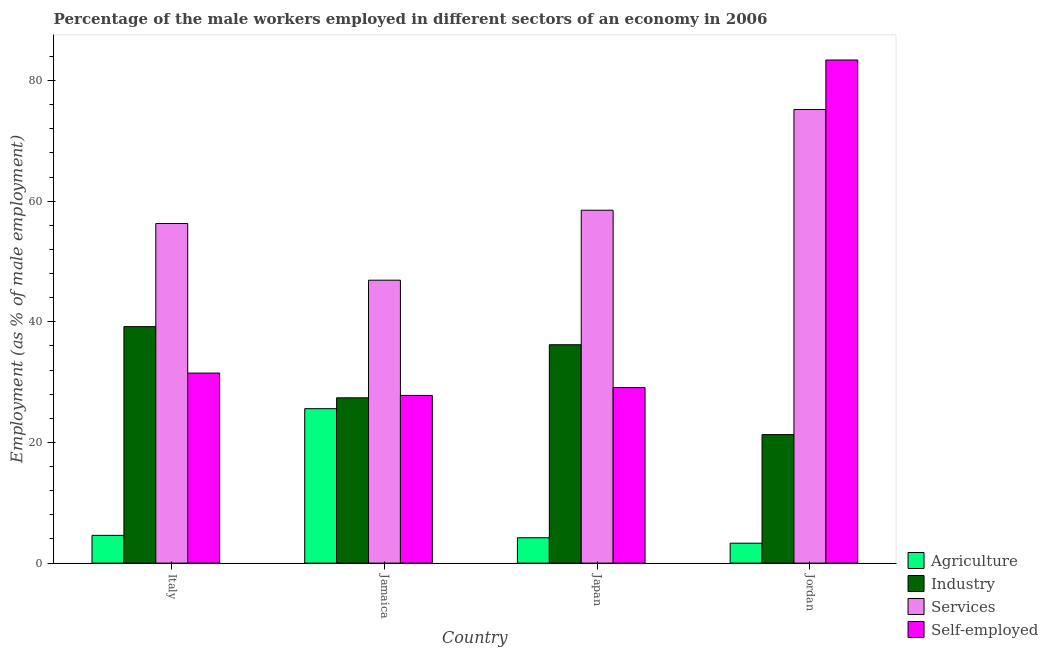How many different coloured bars are there?
Your answer should be compact. 4. How many groups of bars are there?
Give a very brief answer. 4. Are the number of bars per tick equal to the number of legend labels?
Your answer should be compact. Yes. Are the number of bars on each tick of the X-axis equal?
Provide a succinct answer. Yes. What is the percentage of self employed male workers in Jamaica?
Your answer should be compact. 27.8. Across all countries, what is the maximum percentage of self employed male workers?
Provide a short and direct response. 83.4. Across all countries, what is the minimum percentage of self employed male workers?
Keep it short and to the point. 27.8. In which country was the percentage of male workers in agriculture maximum?
Offer a terse response. Jamaica. In which country was the percentage of male workers in industry minimum?
Provide a short and direct response. Jordan. What is the total percentage of male workers in services in the graph?
Give a very brief answer. 236.9. What is the difference between the percentage of male workers in services in Italy and that in Jordan?
Keep it short and to the point. -18.9. What is the difference between the percentage of male workers in industry in Italy and the percentage of male workers in agriculture in Japan?
Offer a very short reply. 35. What is the average percentage of male workers in industry per country?
Provide a succinct answer. 31.03. What is the difference between the percentage of male workers in services and percentage of self employed male workers in Japan?
Offer a very short reply. 29.4. What is the ratio of the percentage of male workers in services in Italy to that in Jordan?
Your answer should be very brief. 0.75. Is the percentage of male workers in services in Jamaica less than that in Jordan?
Give a very brief answer. Yes. What is the difference between the highest and the lowest percentage of male workers in services?
Keep it short and to the point. 28.3. In how many countries, is the percentage of self employed male workers greater than the average percentage of self employed male workers taken over all countries?
Offer a very short reply. 1. Is the sum of the percentage of self employed male workers in Italy and Jordan greater than the maximum percentage of male workers in services across all countries?
Ensure brevity in your answer.  Yes. Is it the case that in every country, the sum of the percentage of male workers in services and percentage of male workers in agriculture is greater than the sum of percentage of self employed male workers and percentage of male workers in industry?
Your answer should be very brief. Yes. What does the 4th bar from the left in Italy represents?
Offer a very short reply. Self-employed. What does the 4th bar from the right in Jamaica represents?
Give a very brief answer. Agriculture. How many bars are there?
Provide a succinct answer. 16. How many countries are there in the graph?
Your answer should be compact. 4. What is the difference between two consecutive major ticks on the Y-axis?
Keep it short and to the point. 20. Where does the legend appear in the graph?
Your response must be concise. Bottom right. How many legend labels are there?
Offer a terse response. 4. What is the title of the graph?
Offer a very short reply. Percentage of the male workers employed in different sectors of an economy in 2006. What is the label or title of the X-axis?
Provide a short and direct response. Country. What is the label or title of the Y-axis?
Your response must be concise. Employment (as % of male employment). What is the Employment (as % of male employment) of Agriculture in Italy?
Give a very brief answer. 4.6. What is the Employment (as % of male employment) of Industry in Italy?
Give a very brief answer. 39.2. What is the Employment (as % of male employment) in Services in Italy?
Keep it short and to the point. 56.3. What is the Employment (as % of male employment) of Self-employed in Italy?
Your answer should be very brief. 31.5. What is the Employment (as % of male employment) of Agriculture in Jamaica?
Provide a short and direct response. 25.6. What is the Employment (as % of male employment) in Industry in Jamaica?
Offer a very short reply. 27.4. What is the Employment (as % of male employment) in Services in Jamaica?
Make the answer very short. 46.9. What is the Employment (as % of male employment) of Self-employed in Jamaica?
Provide a succinct answer. 27.8. What is the Employment (as % of male employment) in Agriculture in Japan?
Give a very brief answer. 4.2. What is the Employment (as % of male employment) of Industry in Japan?
Provide a short and direct response. 36.2. What is the Employment (as % of male employment) in Services in Japan?
Provide a short and direct response. 58.5. What is the Employment (as % of male employment) of Self-employed in Japan?
Offer a terse response. 29.1. What is the Employment (as % of male employment) in Agriculture in Jordan?
Ensure brevity in your answer.  3.3. What is the Employment (as % of male employment) in Industry in Jordan?
Your answer should be very brief. 21.3. What is the Employment (as % of male employment) of Services in Jordan?
Your answer should be very brief. 75.2. What is the Employment (as % of male employment) in Self-employed in Jordan?
Provide a succinct answer. 83.4. Across all countries, what is the maximum Employment (as % of male employment) in Agriculture?
Offer a very short reply. 25.6. Across all countries, what is the maximum Employment (as % of male employment) of Industry?
Your answer should be very brief. 39.2. Across all countries, what is the maximum Employment (as % of male employment) in Services?
Provide a short and direct response. 75.2. Across all countries, what is the maximum Employment (as % of male employment) in Self-employed?
Give a very brief answer. 83.4. Across all countries, what is the minimum Employment (as % of male employment) in Agriculture?
Offer a very short reply. 3.3. Across all countries, what is the minimum Employment (as % of male employment) of Industry?
Keep it short and to the point. 21.3. Across all countries, what is the minimum Employment (as % of male employment) in Services?
Offer a very short reply. 46.9. Across all countries, what is the minimum Employment (as % of male employment) of Self-employed?
Provide a succinct answer. 27.8. What is the total Employment (as % of male employment) in Agriculture in the graph?
Keep it short and to the point. 37.7. What is the total Employment (as % of male employment) in Industry in the graph?
Your answer should be very brief. 124.1. What is the total Employment (as % of male employment) of Services in the graph?
Your response must be concise. 236.9. What is the total Employment (as % of male employment) of Self-employed in the graph?
Your answer should be very brief. 171.8. What is the difference between the Employment (as % of male employment) in Industry in Italy and that in Jamaica?
Make the answer very short. 11.8. What is the difference between the Employment (as % of male employment) in Agriculture in Italy and that in Japan?
Ensure brevity in your answer.  0.4. What is the difference between the Employment (as % of male employment) in Industry in Italy and that in Japan?
Make the answer very short. 3. What is the difference between the Employment (as % of male employment) of Services in Italy and that in Japan?
Offer a terse response. -2.2. What is the difference between the Employment (as % of male employment) of Self-employed in Italy and that in Japan?
Keep it short and to the point. 2.4. What is the difference between the Employment (as % of male employment) of Industry in Italy and that in Jordan?
Your response must be concise. 17.9. What is the difference between the Employment (as % of male employment) of Services in Italy and that in Jordan?
Provide a succinct answer. -18.9. What is the difference between the Employment (as % of male employment) in Self-employed in Italy and that in Jordan?
Give a very brief answer. -51.9. What is the difference between the Employment (as % of male employment) of Agriculture in Jamaica and that in Japan?
Keep it short and to the point. 21.4. What is the difference between the Employment (as % of male employment) of Industry in Jamaica and that in Japan?
Make the answer very short. -8.8. What is the difference between the Employment (as % of male employment) in Self-employed in Jamaica and that in Japan?
Keep it short and to the point. -1.3. What is the difference between the Employment (as % of male employment) in Agriculture in Jamaica and that in Jordan?
Keep it short and to the point. 22.3. What is the difference between the Employment (as % of male employment) of Services in Jamaica and that in Jordan?
Provide a succinct answer. -28.3. What is the difference between the Employment (as % of male employment) of Self-employed in Jamaica and that in Jordan?
Offer a very short reply. -55.6. What is the difference between the Employment (as % of male employment) of Services in Japan and that in Jordan?
Offer a very short reply. -16.7. What is the difference between the Employment (as % of male employment) in Self-employed in Japan and that in Jordan?
Provide a short and direct response. -54.3. What is the difference between the Employment (as % of male employment) of Agriculture in Italy and the Employment (as % of male employment) of Industry in Jamaica?
Keep it short and to the point. -22.8. What is the difference between the Employment (as % of male employment) in Agriculture in Italy and the Employment (as % of male employment) in Services in Jamaica?
Offer a very short reply. -42.3. What is the difference between the Employment (as % of male employment) of Agriculture in Italy and the Employment (as % of male employment) of Self-employed in Jamaica?
Offer a very short reply. -23.2. What is the difference between the Employment (as % of male employment) in Industry in Italy and the Employment (as % of male employment) in Services in Jamaica?
Provide a short and direct response. -7.7. What is the difference between the Employment (as % of male employment) in Industry in Italy and the Employment (as % of male employment) in Self-employed in Jamaica?
Keep it short and to the point. 11.4. What is the difference between the Employment (as % of male employment) in Agriculture in Italy and the Employment (as % of male employment) in Industry in Japan?
Make the answer very short. -31.6. What is the difference between the Employment (as % of male employment) of Agriculture in Italy and the Employment (as % of male employment) of Services in Japan?
Offer a very short reply. -53.9. What is the difference between the Employment (as % of male employment) of Agriculture in Italy and the Employment (as % of male employment) of Self-employed in Japan?
Offer a terse response. -24.5. What is the difference between the Employment (as % of male employment) of Industry in Italy and the Employment (as % of male employment) of Services in Japan?
Your response must be concise. -19.3. What is the difference between the Employment (as % of male employment) of Industry in Italy and the Employment (as % of male employment) of Self-employed in Japan?
Your response must be concise. 10.1. What is the difference between the Employment (as % of male employment) in Services in Italy and the Employment (as % of male employment) in Self-employed in Japan?
Give a very brief answer. 27.2. What is the difference between the Employment (as % of male employment) of Agriculture in Italy and the Employment (as % of male employment) of Industry in Jordan?
Ensure brevity in your answer.  -16.7. What is the difference between the Employment (as % of male employment) in Agriculture in Italy and the Employment (as % of male employment) in Services in Jordan?
Provide a short and direct response. -70.6. What is the difference between the Employment (as % of male employment) of Agriculture in Italy and the Employment (as % of male employment) of Self-employed in Jordan?
Offer a very short reply. -78.8. What is the difference between the Employment (as % of male employment) in Industry in Italy and the Employment (as % of male employment) in Services in Jordan?
Make the answer very short. -36. What is the difference between the Employment (as % of male employment) in Industry in Italy and the Employment (as % of male employment) in Self-employed in Jordan?
Ensure brevity in your answer.  -44.2. What is the difference between the Employment (as % of male employment) in Services in Italy and the Employment (as % of male employment) in Self-employed in Jordan?
Give a very brief answer. -27.1. What is the difference between the Employment (as % of male employment) in Agriculture in Jamaica and the Employment (as % of male employment) in Services in Japan?
Provide a succinct answer. -32.9. What is the difference between the Employment (as % of male employment) of Agriculture in Jamaica and the Employment (as % of male employment) of Self-employed in Japan?
Make the answer very short. -3.5. What is the difference between the Employment (as % of male employment) of Industry in Jamaica and the Employment (as % of male employment) of Services in Japan?
Keep it short and to the point. -31.1. What is the difference between the Employment (as % of male employment) in Industry in Jamaica and the Employment (as % of male employment) in Self-employed in Japan?
Offer a very short reply. -1.7. What is the difference between the Employment (as % of male employment) of Agriculture in Jamaica and the Employment (as % of male employment) of Industry in Jordan?
Your response must be concise. 4.3. What is the difference between the Employment (as % of male employment) in Agriculture in Jamaica and the Employment (as % of male employment) in Services in Jordan?
Your response must be concise. -49.6. What is the difference between the Employment (as % of male employment) in Agriculture in Jamaica and the Employment (as % of male employment) in Self-employed in Jordan?
Make the answer very short. -57.8. What is the difference between the Employment (as % of male employment) of Industry in Jamaica and the Employment (as % of male employment) of Services in Jordan?
Offer a terse response. -47.8. What is the difference between the Employment (as % of male employment) of Industry in Jamaica and the Employment (as % of male employment) of Self-employed in Jordan?
Make the answer very short. -56. What is the difference between the Employment (as % of male employment) in Services in Jamaica and the Employment (as % of male employment) in Self-employed in Jordan?
Keep it short and to the point. -36.5. What is the difference between the Employment (as % of male employment) of Agriculture in Japan and the Employment (as % of male employment) of Industry in Jordan?
Ensure brevity in your answer.  -17.1. What is the difference between the Employment (as % of male employment) of Agriculture in Japan and the Employment (as % of male employment) of Services in Jordan?
Provide a short and direct response. -71. What is the difference between the Employment (as % of male employment) of Agriculture in Japan and the Employment (as % of male employment) of Self-employed in Jordan?
Your answer should be compact. -79.2. What is the difference between the Employment (as % of male employment) of Industry in Japan and the Employment (as % of male employment) of Services in Jordan?
Give a very brief answer. -39. What is the difference between the Employment (as % of male employment) in Industry in Japan and the Employment (as % of male employment) in Self-employed in Jordan?
Offer a very short reply. -47.2. What is the difference between the Employment (as % of male employment) of Services in Japan and the Employment (as % of male employment) of Self-employed in Jordan?
Make the answer very short. -24.9. What is the average Employment (as % of male employment) in Agriculture per country?
Offer a very short reply. 9.43. What is the average Employment (as % of male employment) of Industry per country?
Your response must be concise. 31.02. What is the average Employment (as % of male employment) in Services per country?
Your response must be concise. 59.23. What is the average Employment (as % of male employment) in Self-employed per country?
Your answer should be compact. 42.95. What is the difference between the Employment (as % of male employment) of Agriculture and Employment (as % of male employment) of Industry in Italy?
Your response must be concise. -34.6. What is the difference between the Employment (as % of male employment) in Agriculture and Employment (as % of male employment) in Services in Italy?
Ensure brevity in your answer.  -51.7. What is the difference between the Employment (as % of male employment) in Agriculture and Employment (as % of male employment) in Self-employed in Italy?
Make the answer very short. -26.9. What is the difference between the Employment (as % of male employment) in Industry and Employment (as % of male employment) in Services in Italy?
Offer a very short reply. -17.1. What is the difference between the Employment (as % of male employment) in Services and Employment (as % of male employment) in Self-employed in Italy?
Make the answer very short. 24.8. What is the difference between the Employment (as % of male employment) of Agriculture and Employment (as % of male employment) of Services in Jamaica?
Offer a terse response. -21.3. What is the difference between the Employment (as % of male employment) in Agriculture and Employment (as % of male employment) in Self-employed in Jamaica?
Ensure brevity in your answer.  -2.2. What is the difference between the Employment (as % of male employment) in Industry and Employment (as % of male employment) in Services in Jamaica?
Offer a terse response. -19.5. What is the difference between the Employment (as % of male employment) in Industry and Employment (as % of male employment) in Self-employed in Jamaica?
Your answer should be very brief. -0.4. What is the difference between the Employment (as % of male employment) of Services and Employment (as % of male employment) of Self-employed in Jamaica?
Keep it short and to the point. 19.1. What is the difference between the Employment (as % of male employment) of Agriculture and Employment (as % of male employment) of Industry in Japan?
Your response must be concise. -32. What is the difference between the Employment (as % of male employment) in Agriculture and Employment (as % of male employment) in Services in Japan?
Your answer should be very brief. -54.3. What is the difference between the Employment (as % of male employment) in Agriculture and Employment (as % of male employment) in Self-employed in Japan?
Offer a terse response. -24.9. What is the difference between the Employment (as % of male employment) of Industry and Employment (as % of male employment) of Services in Japan?
Ensure brevity in your answer.  -22.3. What is the difference between the Employment (as % of male employment) of Industry and Employment (as % of male employment) of Self-employed in Japan?
Provide a succinct answer. 7.1. What is the difference between the Employment (as % of male employment) of Services and Employment (as % of male employment) of Self-employed in Japan?
Offer a very short reply. 29.4. What is the difference between the Employment (as % of male employment) of Agriculture and Employment (as % of male employment) of Industry in Jordan?
Provide a succinct answer. -18. What is the difference between the Employment (as % of male employment) of Agriculture and Employment (as % of male employment) of Services in Jordan?
Offer a terse response. -71.9. What is the difference between the Employment (as % of male employment) of Agriculture and Employment (as % of male employment) of Self-employed in Jordan?
Offer a very short reply. -80.1. What is the difference between the Employment (as % of male employment) in Industry and Employment (as % of male employment) in Services in Jordan?
Ensure brevity in your answer.  -53.9. What is the difference between the Employment (as % of male employment) in Industry and Employment (as % of male employment) in Self-employed in Jordan?
Keep it short and to the point. -62.1. What is the ratio of the Employment (as % of male employment) in Agriculture in Italy to that in Jamaica?
Provide a succinct answer. 0.18. What is the ratio of the Employment (as % of male employment) of Industry in Italy to that in Jamaica?
Offer a terse response. 1.43. What is the ratio of the Employment (as % of male employment) in Services in Italy to that in Jamaica?
Keep it short and to the point. 1.2. What is the ratio of the Employment (as % of male employment) in Self-employed in Italy to that in Jamaica?
Your response must be concise. 1.13. What is the ratio of the Employment (as % of male employment) in Agriculture in Italy to that in Japan?
Ensure brevity in your answer.  1.1. What is the ratio of the Employment (as % of male employment) in Industry in Italy to that in Japan?
Your answer should be compact. 1.08. What is the ratio of the Employment (as % of male employment) in Services in Italy to that in Japan?
Your answer should be very brief. 0.96. What is the ratio of the Employment (as % of male employment) of Self-employed in Italy to that in Japan?
Give a very brief answer. 1.08. What is the ratio of the Employment (as % of male employment) in Agriculture in Italy to that in Jordan?
Ensure brevity in your answer.  1.39. What is the ratio of the Employment (as % of male employment) of Industry in Italy to that in Jordan?
Give a very brief answer. 1.84. What is the ratio of the Employment (as % of male employment) of Services in Italy to that in Jordan?
Your answer should be compact. 0.75. What is the ratio of the Employment (as % of male employment) in Self-employed in Italy to that in Jordan?
Offer a terse response. 0.38. What is the ratio of the Employment (as % of male employment) of Agriculture in Jamaica to that in Japan?
Your answer should be very brief. 6.1. What is the ratio of the Employment (as % of male employment) of Industry in Jamaica to that in Japan?
Your answer should be very brief. 0.76. What is the ratio of the Employment (as % of male employment) of Services in Jamaica to that in Japan?
Offer a terse response. 0.8. What is the ratio of the Employment (as % of male employment) in Self-employed in Jamaica to that in Japan?
Ensure brevity in your answer.  0.96. What is the ratio of the Employment (as % of male employment) in Agriculture in Jamaica to that in Jordan?
Offer a very short reply. 7.76. What is the ratio of the Employment (as % of male employment) of Industry in Jamaica to that in Jordan?
Ensure brevity in your answer.  1.29. What is the ratio of the Employment (as % of male employment) in Services in Jamaica to that in Jordan?
Keep it short and to the point. 0.62. What is the ratio of the Employment (as % of male employment) in Self-employed in Jamaica to that in Jordan?
Ensure brevity in your answer.  0.33. What is the ratio of the Employment (as % of male employment) of Agriculture in Japan to that in Jordan?
Your answer should be very brief. 1.27. What is the ratio of the Employment (as % of male employment) in Industry in Japan to that in Jordan?
Provide a succinct answer. 1.7. What is the ratio of the Employment (as % of male employment) of Services in Japan to that in Jordan?
Keep it short and to the point. 0.78. What is the ratio of the Employment (as % of male employment) in Self-employed in Japan to that in Jordan?
Your answer should be compact. 0.35. What is the difference between the highest and the second highest Employment (as % of male employment) of Services?
Make the answer very short. 16.7. What is the difference between the highest and the second highest Employment (as % of male employment) of Self-employed?
Your answer should be very brief. 51.9. What is the difference between the highest and the lowest Employment (as % of male employment) in Agriculture?
Ensure brevity in your answer.  22.3. What is the difference between the highest and the lowest Employment (as % of male employment) in Services?
Keep it short and to the point. 28.3. What is the difference between the highest and the lowest Employment (as % of male employment) in Self-employed?
Keep it short and to the point. 55.6. 